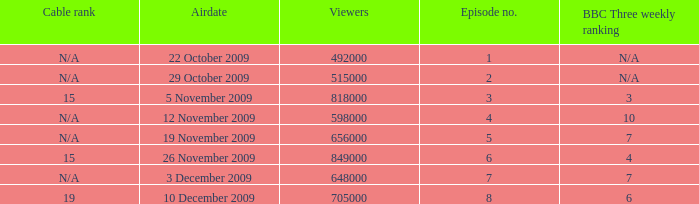Where where the bbc three weekly ranking for episode no. 5? 7.0. 